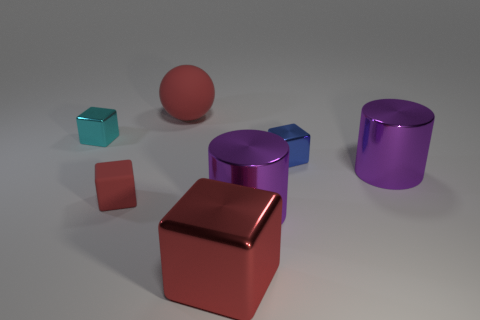Describe the surface the objects are resting on. The objects are resting on a smooth, matte surface that seems to be uniformly lit. There's no texture or pattern, giving the scene a clean, minimalistic look. 